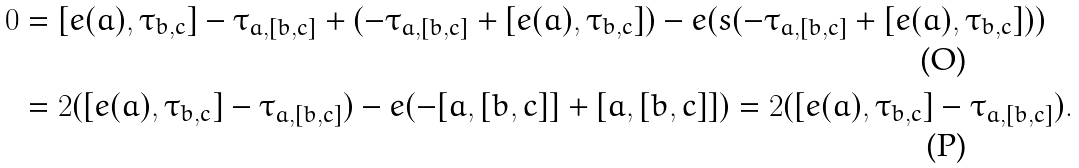Convert formula to latex. <formula><loc_0><loc_0><loc_500><loc_500>0 & = [ e ( a ) , \tau _ { b , c } ] - \tau _ { a , [ b , c ] } + ( - \tau _ { a , [ b , c ] } + [ e ( a ) , \tau _ { b , c } ] ) - e ( s ( - \tau _ { a , [ b , c ] } + [ e ( a ) , \tau _ { b , c } ] ) ) \\ & = 2 ( [ e ( a ) , \tau _ { b , c } ] - \tau _ { a , [ b , c ] } ) - e ( - [ a , [ b , c ] ] + [ a , [ b , c ] ] ) = 2 ( [ e ( a ) , \tau _ { b , c } ] - \tau _ { a , [ b , c ] } ) .</formula> 